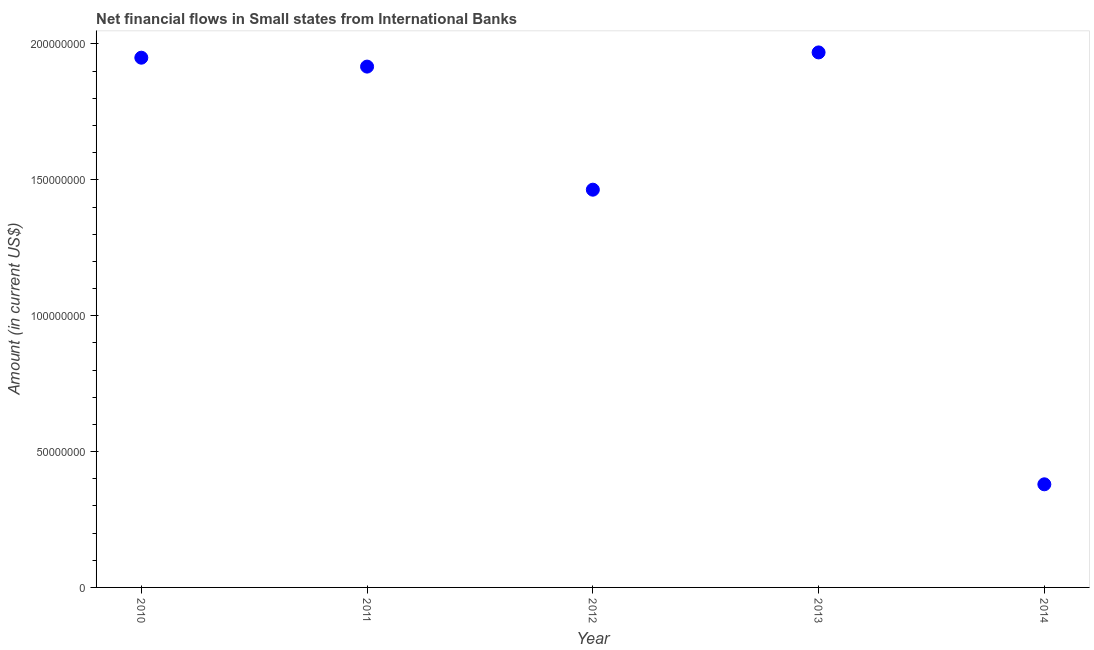What is the net financial flows from ibrd in 2013?
Give a very brief answer. 1.97e+08. Across all years, what is the maximum net financial flows from ibrd?
Offer a terse response. 1.97e+08. Across all years, what is the minimum net financial flows from ibrd?
Provide a short and direct response. 3.80e+07. In which year was the net financial flows from ibrd maximum?
Offer a terse response. 2013. What is the sum of the net financial flows from ibrd?
Provide a short and direct response. 7.68e+08. What is the difference between the net financial flows from ibrd in 2011 and 2014?
Give a very brief answer. 1.54e+08. What is the average net financial flows from ibrd per year?
Offer a very short reply. 1.54e+08. What is the median net financial flows from ibrd?
Keep it short and to the point. 1.92e+08. In how many years, is the net financial flows from ibrd greater than 100000000 US$?
Provide a short and direct response. 4. What is the ratio of the net financial flows from ibrd in 2010 to that in 2014?
Ensure brevity in your answer.  5.14. What is the difference between the highest and the second highest net financial flows from ibrd?
Provide a succinct answer. 1.94e+06. Is the sum of the net financial flows from ibrd in 2011 and 2013 greater than the maximum net financial flows from ibrd across all years?
Provide a short and direct response. Yes. What is the difference between the highest and the lowest net financial flows from ibrd?
Give a very brief answer. 1.59e+08. In how many years, is the net financial flows from ibrd greater than the average net financial flows from ibrd taken over all years?
Offer a terse response. 3. How many years are there in the graph?
Offer a very short reply. 5. What is the difference between two consecutive major ticks on the Y-axis?
Keep it short and to the point. 5.00e+07. Are the values on the major ticks of Y-axis written in scientific E-notation?
Offer a terse response. No. Does the graph contain any zero values?
Your answer should be very brief. No. What is the title of the graph?
Ensure brevity in your answer.  Net financial flows in Small states from International Banks. What is the label or title of the X-axis?
Your answer should be very brief. Year. What is the Amount (in current US$) in 2010?
Provide a succinct answer. 1.95e+08. What is the Amount (in current US$) in 2011?
Your response must be concise. 1.92e+08. What is the Amount (in current US$) in 2012?
Keep it short and to the point. 1.46e+08. What is the Amount (in current US$) in 2013?
Your response must be concise. 1.97e+08. What is the Amount (in current US$) in 2014?
Provide a short and direct response. 3.80e+07. What is the difference between the Amount (in current US$) in 2010 and 2011?
Your response must be concise. 3.28e+06. What is the difference between the Amount (in current US$) in 2010 and 2012?
Your response must be concise. 4.86e+07. What is the difference between the Amount (in current US$) in 2010 and 2013?
Make the answer very short. -1.94e+06. What is the difference between the Amount (in current US$) in 2010 and 2014?
Your response must be concise. 1.57e+08. What is the difference between the Amount (in current US$) in 2011 and 2012?
Keep it short and to the point. 4.53e+07. What is the difference between the Amount (in current US$) in 2011 and 2013?
Provide a succinct answer. -5.22e+06. What is the difference between the Amount (in current US$) in 2011 and 2014?
Give a very brief answer. 1.54e+08. What is the difference between the Amount (in current US$) in 2012 and 2013?
Ensure brevity in your answer.  -5.05e+07. What is the difference between the Amount (in current US$) in 2012 and 2014?
Give a very brief answer. 1.08e+08. What is the difference between the Amount (in current US$) in 2013 and 2014?
Your response must be concise. 1.59e+08. What is the ratio of the Amount (in current US$) in 2010 to that in 2012?
Offer a very short reply. 1.33. What is the ratio of the Amount (in current US$) in 2010 to that in 2013?
Your response must be concise. 0.99. What is the ratio of the Amount (in current US$) in 2010 to that in 2014?
Offer a terse response. 5.14. What is the ratio of the Amount (in current US$) in 2011 to that in 2012?
Make the answer very short. 1.31. What is the ratio of the Amount (in current US$) in 2011 to that in 2014?
Provide a short and direct response. 5.05. What is the ratio of the Amount (in current US$) in 2012 to that in 2013?
Your response must be concise. 0.74. What is the ratio of the Amount (in current US$) in 2012 to that in 2014?
Give a very brief answer. 3.86. What is the ratio of the Amount (in current US$) in 2013 to that in 2014?
Your answer should be very brief. 5.19. 